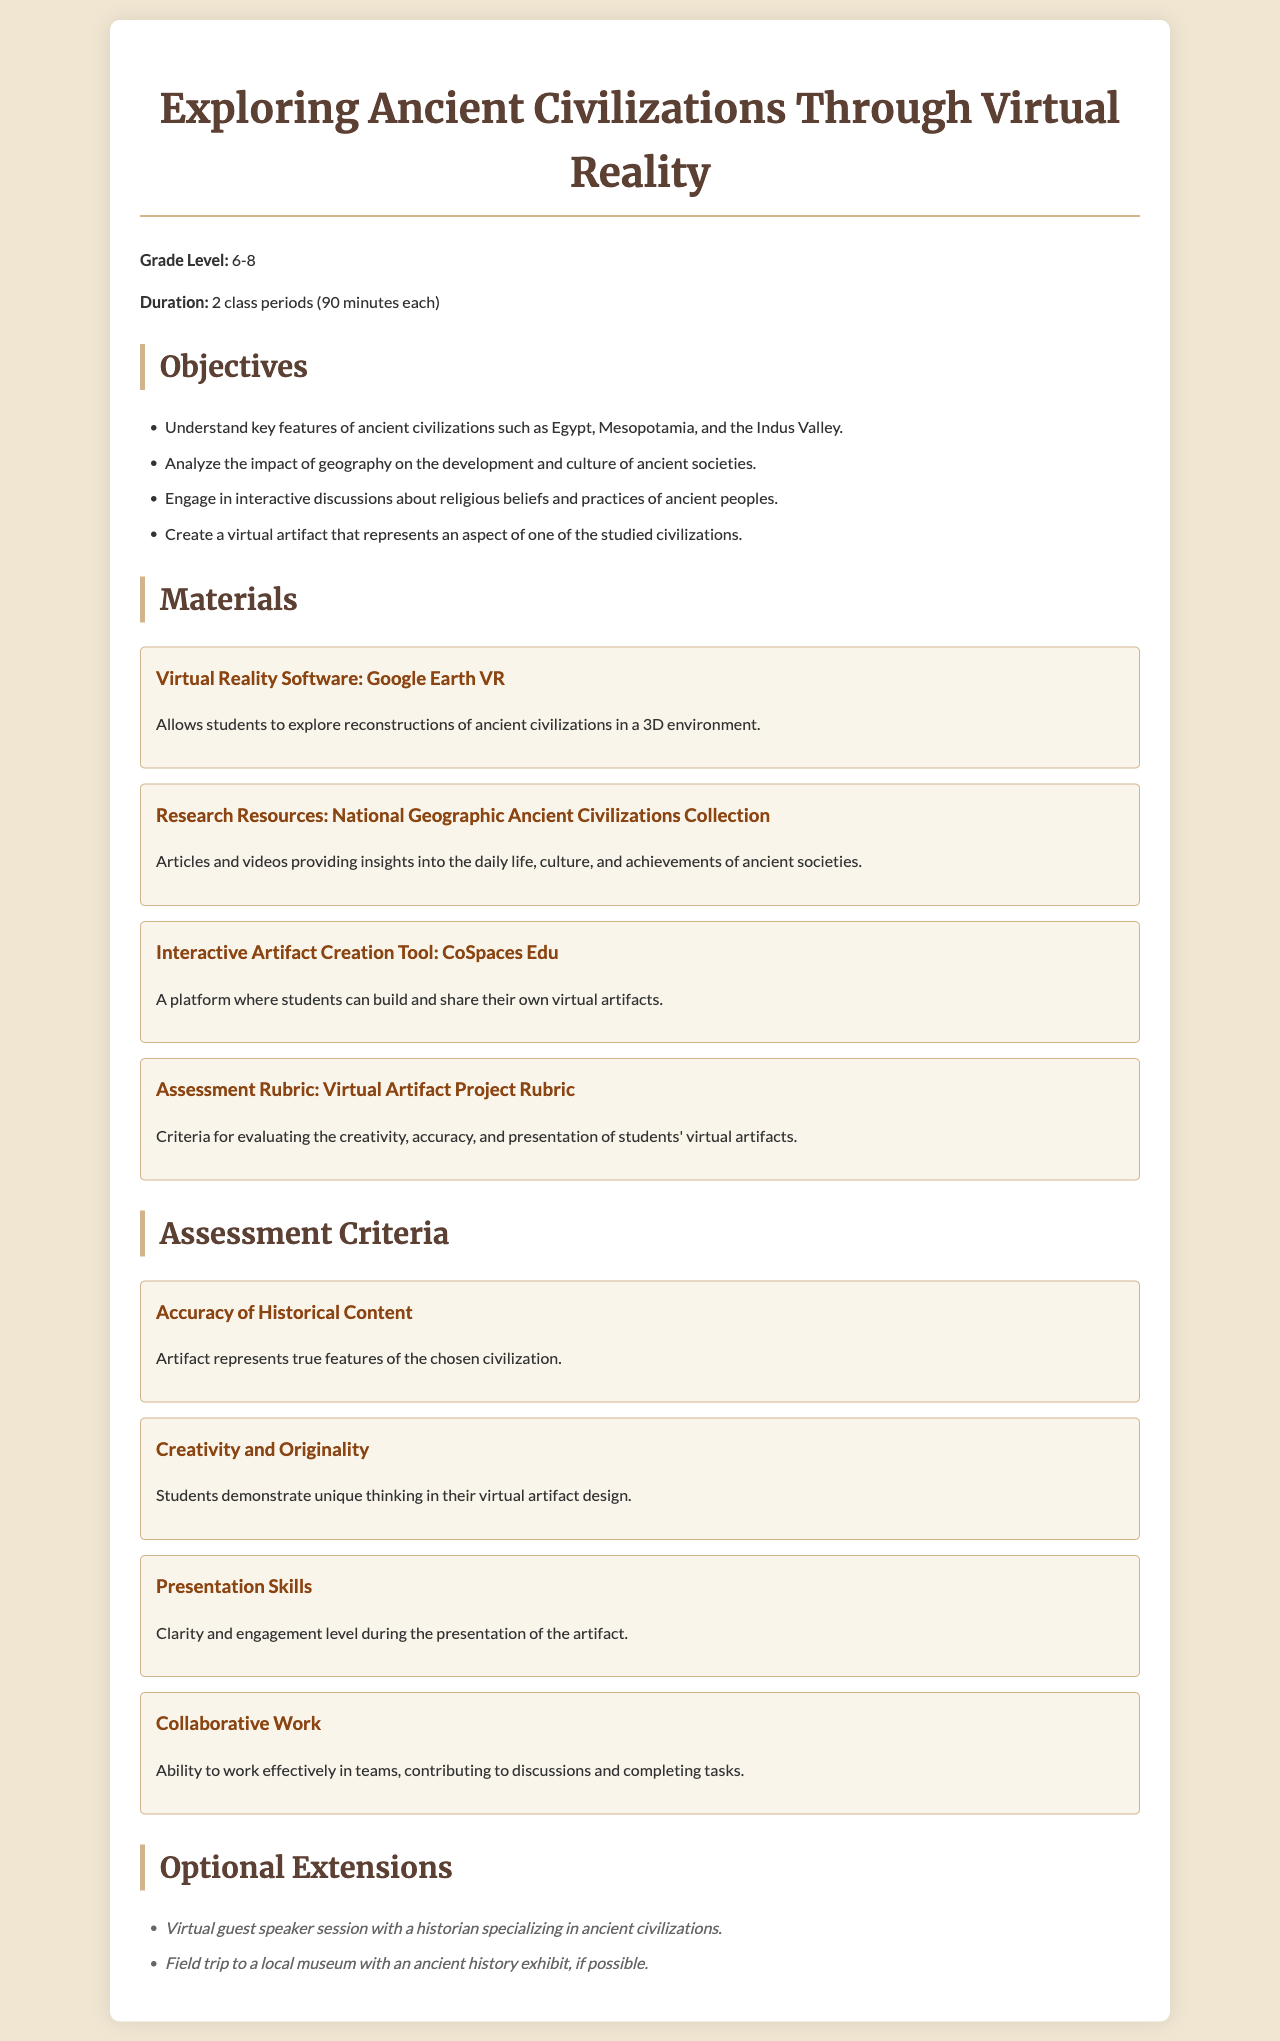what is the grade level for the lesson plan? The grade level indicated in the document specifies the target audience for the lesson, which is grades 6-8.
Answer: 6-8 how long is the duration of the lesson plan? The document states that the duration of the lesson plan consists of two class periods, each lasting 90 minutes.
Answer: 2 class periods (90 minutes each) which VR software is used in the lesson? The document specifies that Google Earth VR is the virtual reality software utilized in this lesson plan.
Answer: Google Earth VR what is one objective of the lesson? The document lists several objectives, one of which is to engage in interactive discussions about religious beliefs and practices of ancient peoples.
Answer: Engage in interactive discussions about religious beliefs and practices how many assessment criteria are listed? The document details four assessment criteria for evaluating students' performance in the project.
Answer: 4 which tool is mentioned for creating virtual artifacts? The document indicates that CoSpaces Edu is the interactive artifact creation tool used in the lesson.
Answer: CoSpaces Edu what is one optional extension mentioned? The document suggests a virtual guest speaker session with a historian as an optional extension.
Answer: Virtual guest speaker session how is creativity evaluated in the assessment criteria? The document specifies that creativity and originality are assessed by students demonstrating unique thinking in their virtual artifact design.
Answer: Students demonstrate unique thinking in their virtual artifact design what is the color scheme of the document background? The document mentions a beige background color, which provides a warm and neutral aesthetic for the presentation.
Answer: #f0e6d2 